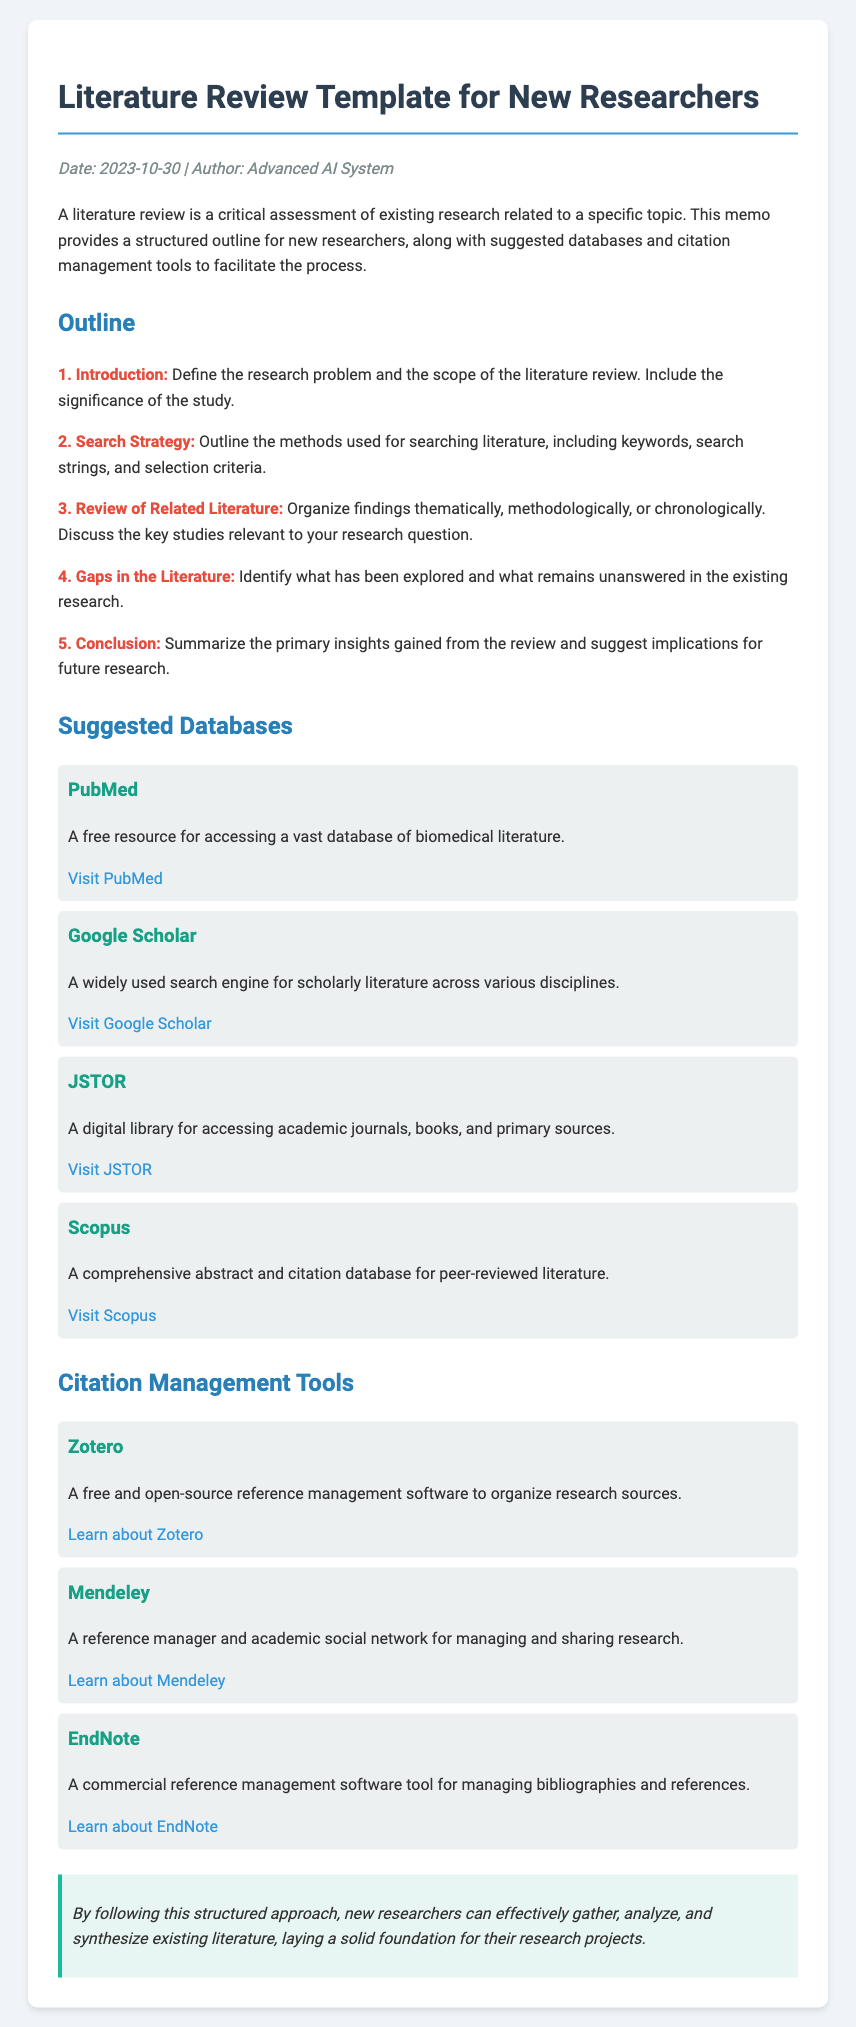What is the date of the memo? The date of the memo is mentioned in the meta section as 2023-10-30.
Answer: 2023-10-30 Who is the author of the memo? The author of the memo is specified in the meta section as Advanced AI System.
Answer: Advanced AI System What is the first item in the outline? The first item in the outline is “Introduction,” which defines the research problem and scope.
Answer: Introduction Which database is described as a free resource for biomedical literature? The memo describes PubMed as a free resource for accessing a vast database of biomedical literature.
Answer: PubMed Name one citation management tool mentioned in the document. The document lists several tools, including Zotero, Mendeley, and EndNote.
Answer: Zotero What is the primary purpose of a literature review? The primary purpose of a literature review is to provide a critical assessment of existing research related to a specific topic.
Answer: Critical assessment How many sections are there in the document? The document contains five sections: Outline, Suggested Databases, Citation Management Tools, and Conclusion.
Answer: Four What type of document is this? This document is identified as a memo intended for new researchers.
Answer: Memo What do the suggested databases help with? The suggested databases help researchers access various academic literature for their reviews.
Answer: Access academic literature 